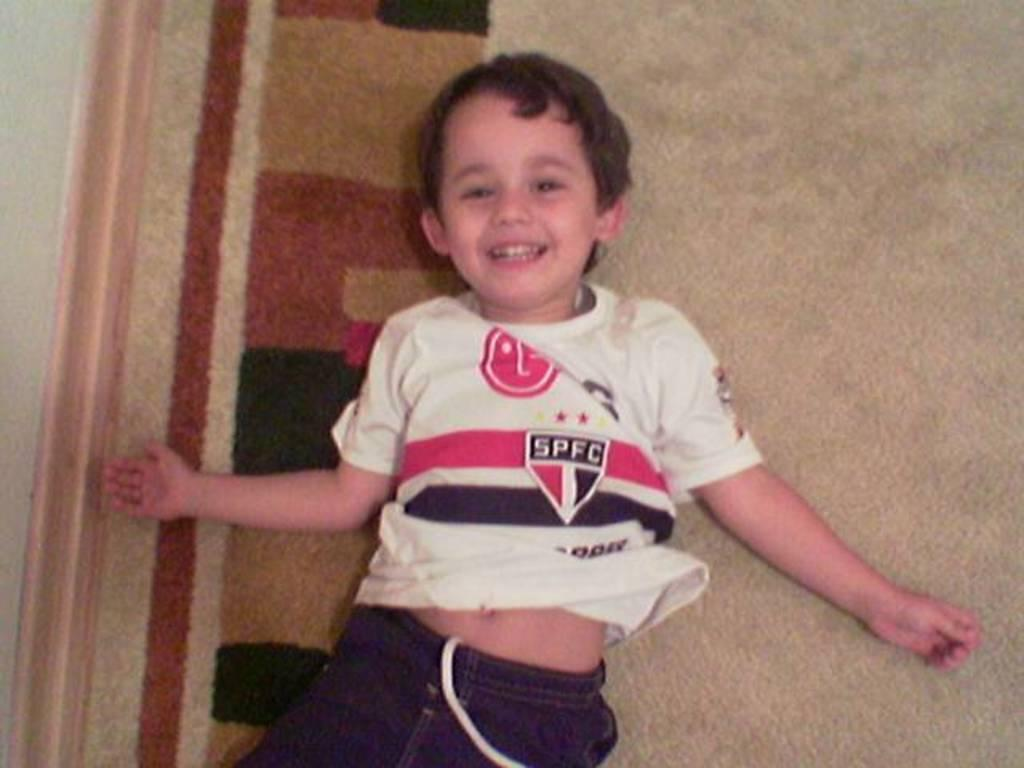Provide a one-sentence caption for the provided image. A young boy wears a shirt with the name SPFC. 